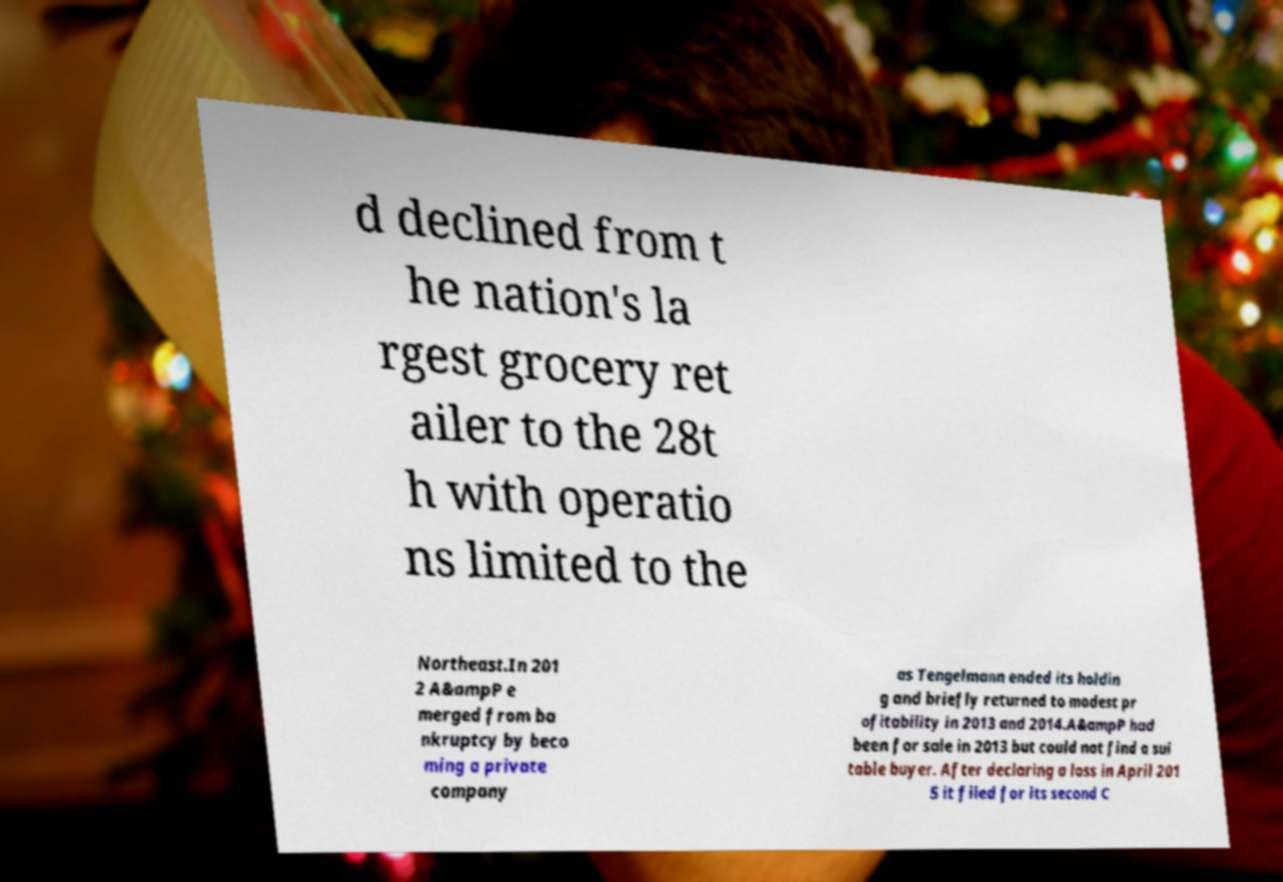There's text embedded in this image that I need extracted. Can you transcribe it verbatim? d declined from t he nation's la rgest grocery ret ailer to the 28t h with operatio ns limited to the Northeast.In 201 2 A&ampP e merged from ba nkruptcy by beco ming a private company as Tengelmann ended its holdin g and briefly returned to modest pr ofitability in 2013 and 2014.A&ampP had been for sale in 2013 but could not find a sui table buyer. After declaring a loss in April 201 5 it filed for its second C 